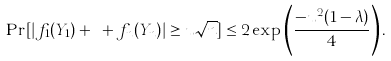<formula> <loc_0><loc_0><loc_500><loc_500>\Pr [ | f _ { 1 } ( Y _ { 1 } ) + \cdots + f _ { n } ( Y _ { n } ) | \geq u \sqrt { n } ] \leq 2 \exp \left ( \frac { - u ^ { 2 } ( 1 - \lambda ) } { 4 } \right ) .</formula> 